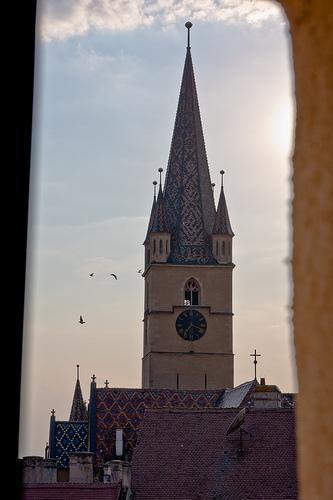How many crosses?
Give a very brief answer. 1. 